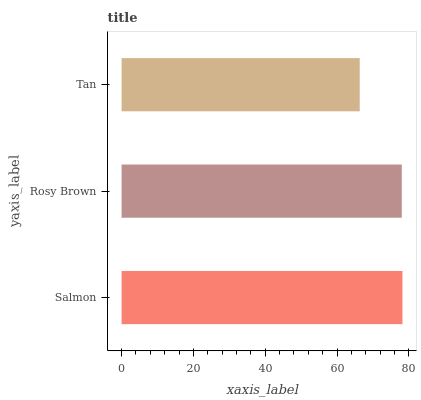Is Tan the minimum?
Answer yes or no. Yes. Is Salmon the maximum?
Answer yes or no. Yes. Is Rosy Brown the minimum?
Answer yes or no. No. Is Rosy Brown the maximum?
Answer yes or no. No. Is Salmon greater than Rosy Brown?
Answer yes or no. Yes. Is Rosy Brown less than Salmon?
Answer yes or no. Yes. Is Rosy Brown greater than Salmon?
Answer yes or no. No. Is Salmon less than Rosy Brown?
Answer yes or no. No. Is Rosy Brown the high median?
Answer yes or no. Yes. Is Rosy Brown the low median?
Answer yes or no. Yes. Is Salmon the high median?
Answer yes or no. No. Is Salmon the low median?
Answer yes or no. No. 